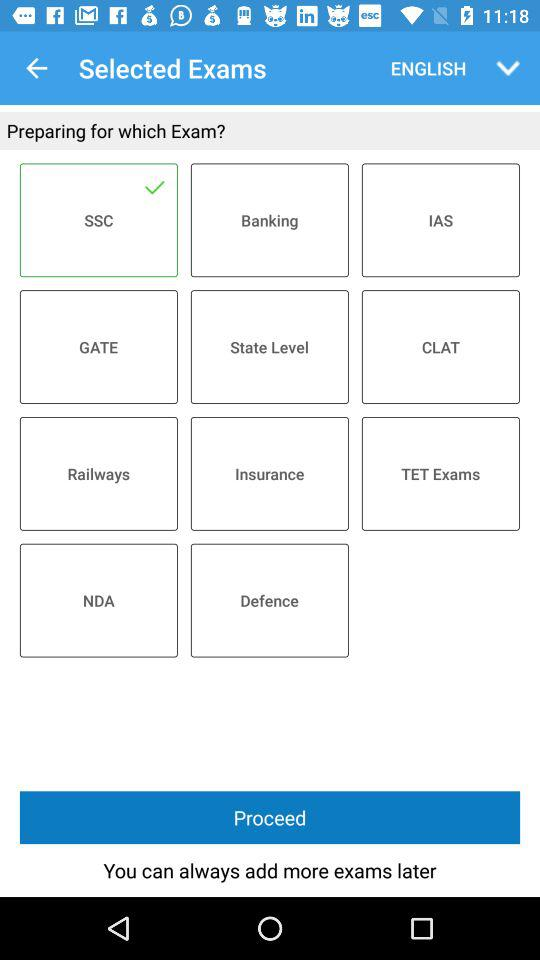How many questions are in the exam?
When the provided information is insufficient, respond with <no answer>. <no answer> 